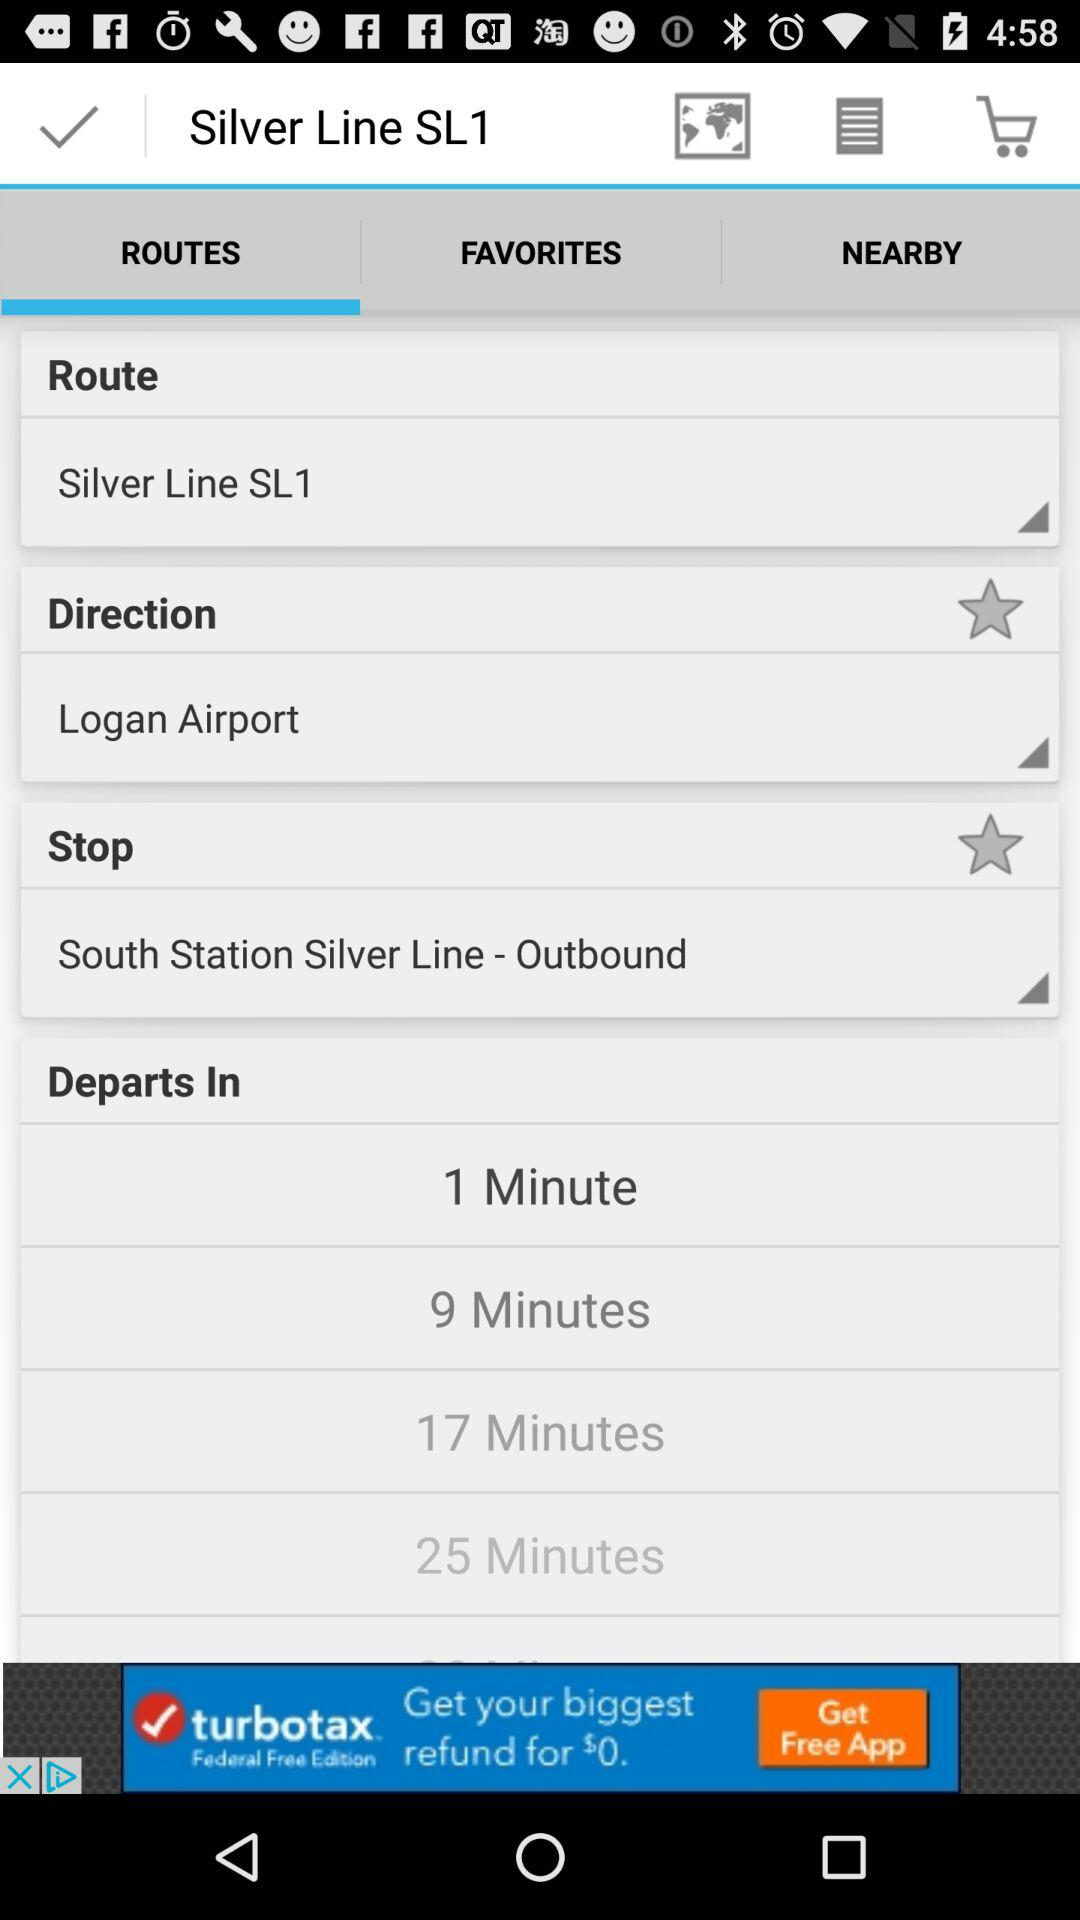How many more minutes are there between the 25 minute and 17 minute departures?
Answer the question using a single word or phrase. 8 